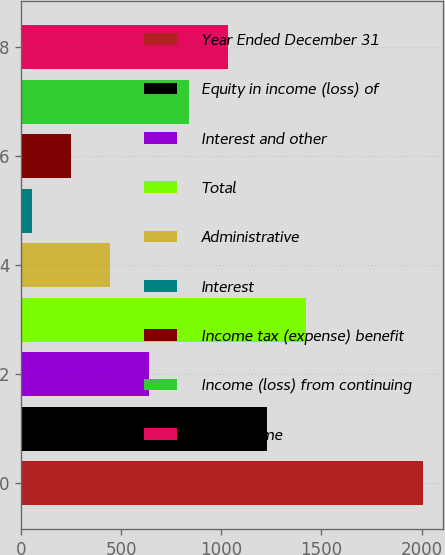Convert chart. <chart><loc_0><loc_0><loc_500><loc_500><bar_chart><fcel>Year Ended December 31<fcel>Equity in income (loss) of<fcel>Interest and other<fcel>Total<fcel>Administrative<fcel>Interest<fcel>Income tax (expense) benefit<fcel>Income (loss) from continuing<fcel>Net income<nl><fcel>2009<fcel>1227.4<fcel>641.2<fcel>1422.8<fcel>445.8<fcel>55<fcel>250.4<fcel>836.6<fcel>1032<nl></chart> 